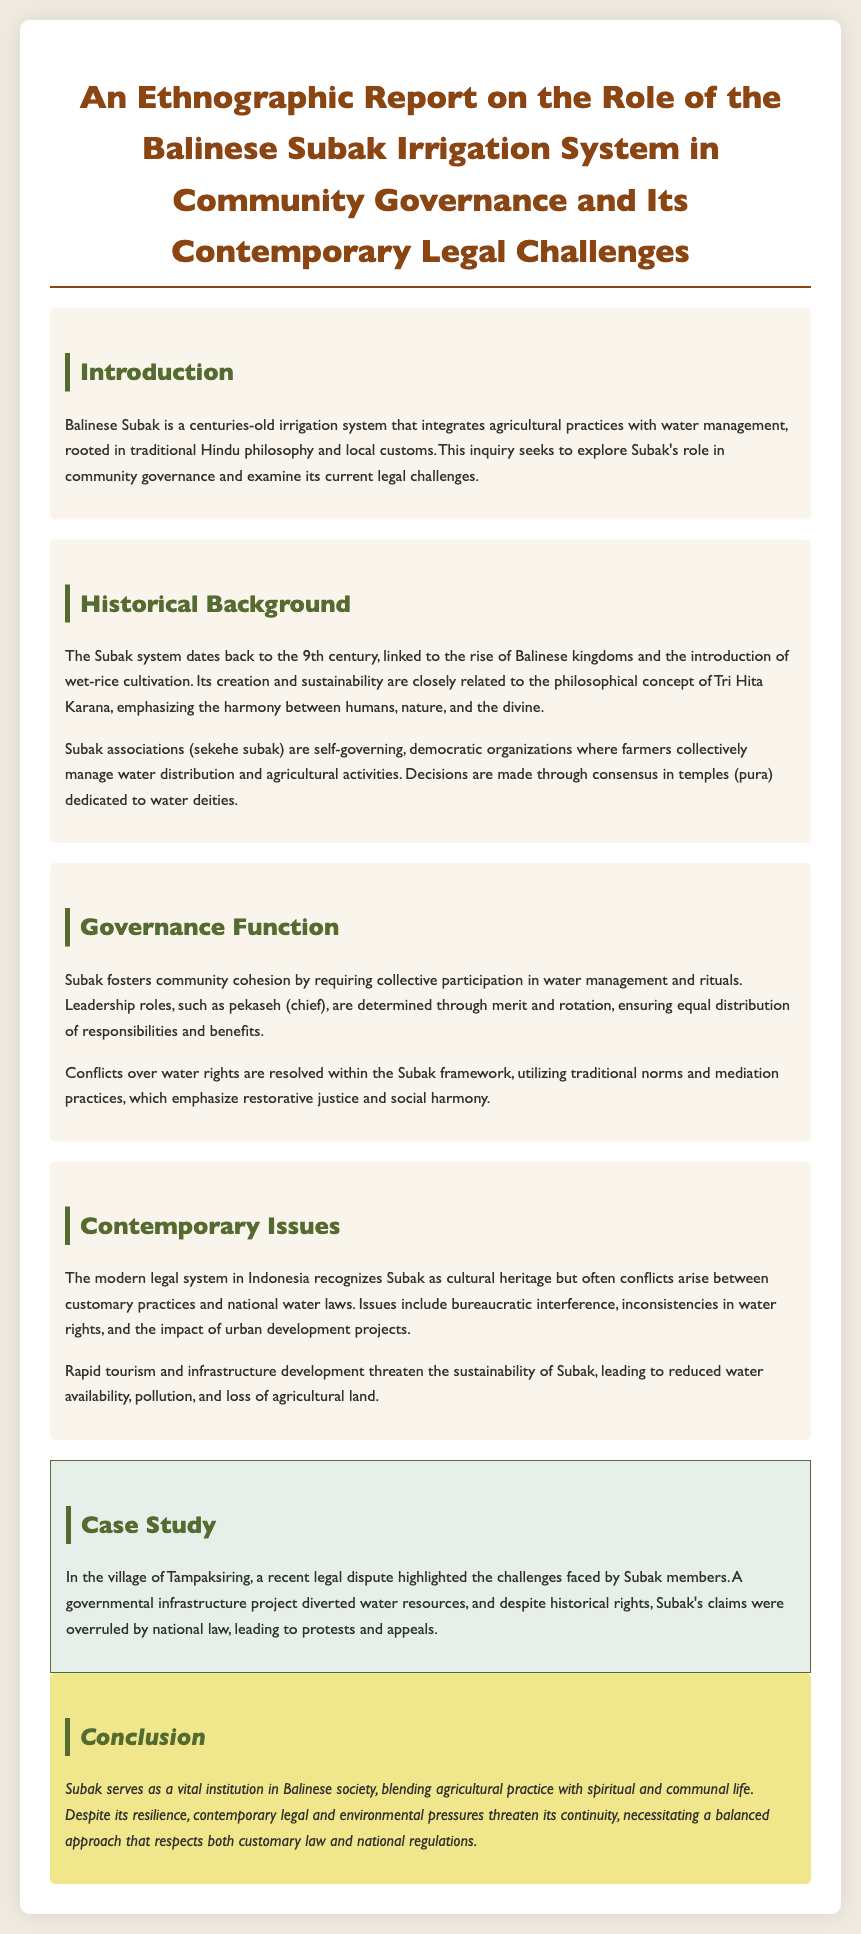what is the title of the report? The title clearly states the subject of the document regarding the Balinese Subak irrigation system and its governance and legal challenges.
Answer: An Ethnographic Report on the Role of the Balinese Subak Irrigation System in Community Governance and Its Contemporary Legal Challenges what century does the Subak system date back to? The document provides a specific time frame for the establishment of the Subak system within its historical background section.
Answer: 9th century what is the philosophical concept associated with the Subak system? The document mentions this concept in relation to the sustainability and creation of the Subak system.
Answer: Tri Hita Karana what role does the pekaseh hold in Subak governance? This role is described in the governance section, indicating its significance in leadership and decision-making within Subak.
Answer: chief what legal issue was highlighted in the case study? The case study section of the document outlines a specific legal challenge faced by Subak members, providing insight into contemporary issues.
Answer: water resource diversion what impact does urban development have on Subak? The document discusses the consequences of urbanization on the sustainability of the Subak system within contemporary issues.
Answer: threatens sustainability how are conflicts over water rights resolved in Subak? The governance section outlines the resolution process for conflicts, emphasizing traditional approaches.
Answer: traditional norms and mediation practices which village is mentioned in the case study? The case study provides a specific location where legal disputes regarding Subak occurred, illustrating contemporary challenges.
Answer: Tampaksiring how is Subak recognized in the modern legal system of Indonesia? The document mentions its recognition, correlating to the relationship between customary practices and national laws.
Answer: cultural heritage 